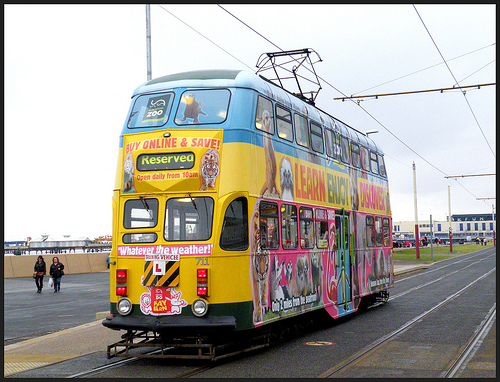<image>
Is there a electric cab on the rail? Yes. Looking at the image, I can see the electric cab is positioned on top of the rail, with the rail providing support. 